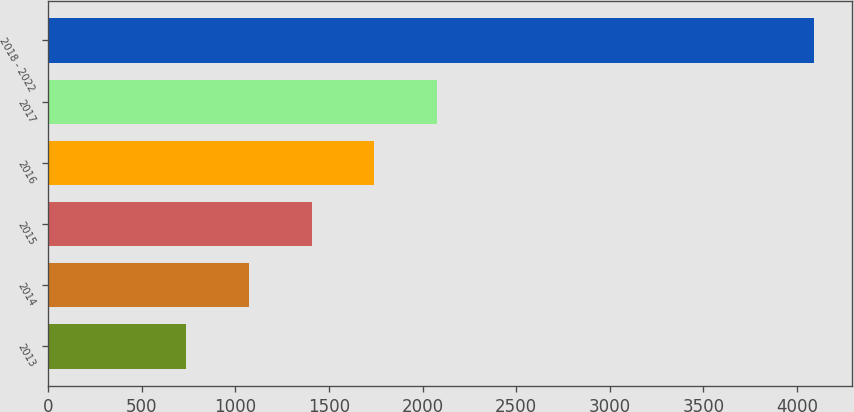Convert chart. <chart><loc_0><loc_0><loc_500><loc_500><bar_chart><fcel>2013<fcel>2014<fcel>2015<fcel>2016<fcel>2017<fcel>2018 - 2022<nl><fcel>736<fcel>1071.4<fcel>1406.8<fcel>1742.2<fcel>2077.6<fcel>4090<nl></chart> 